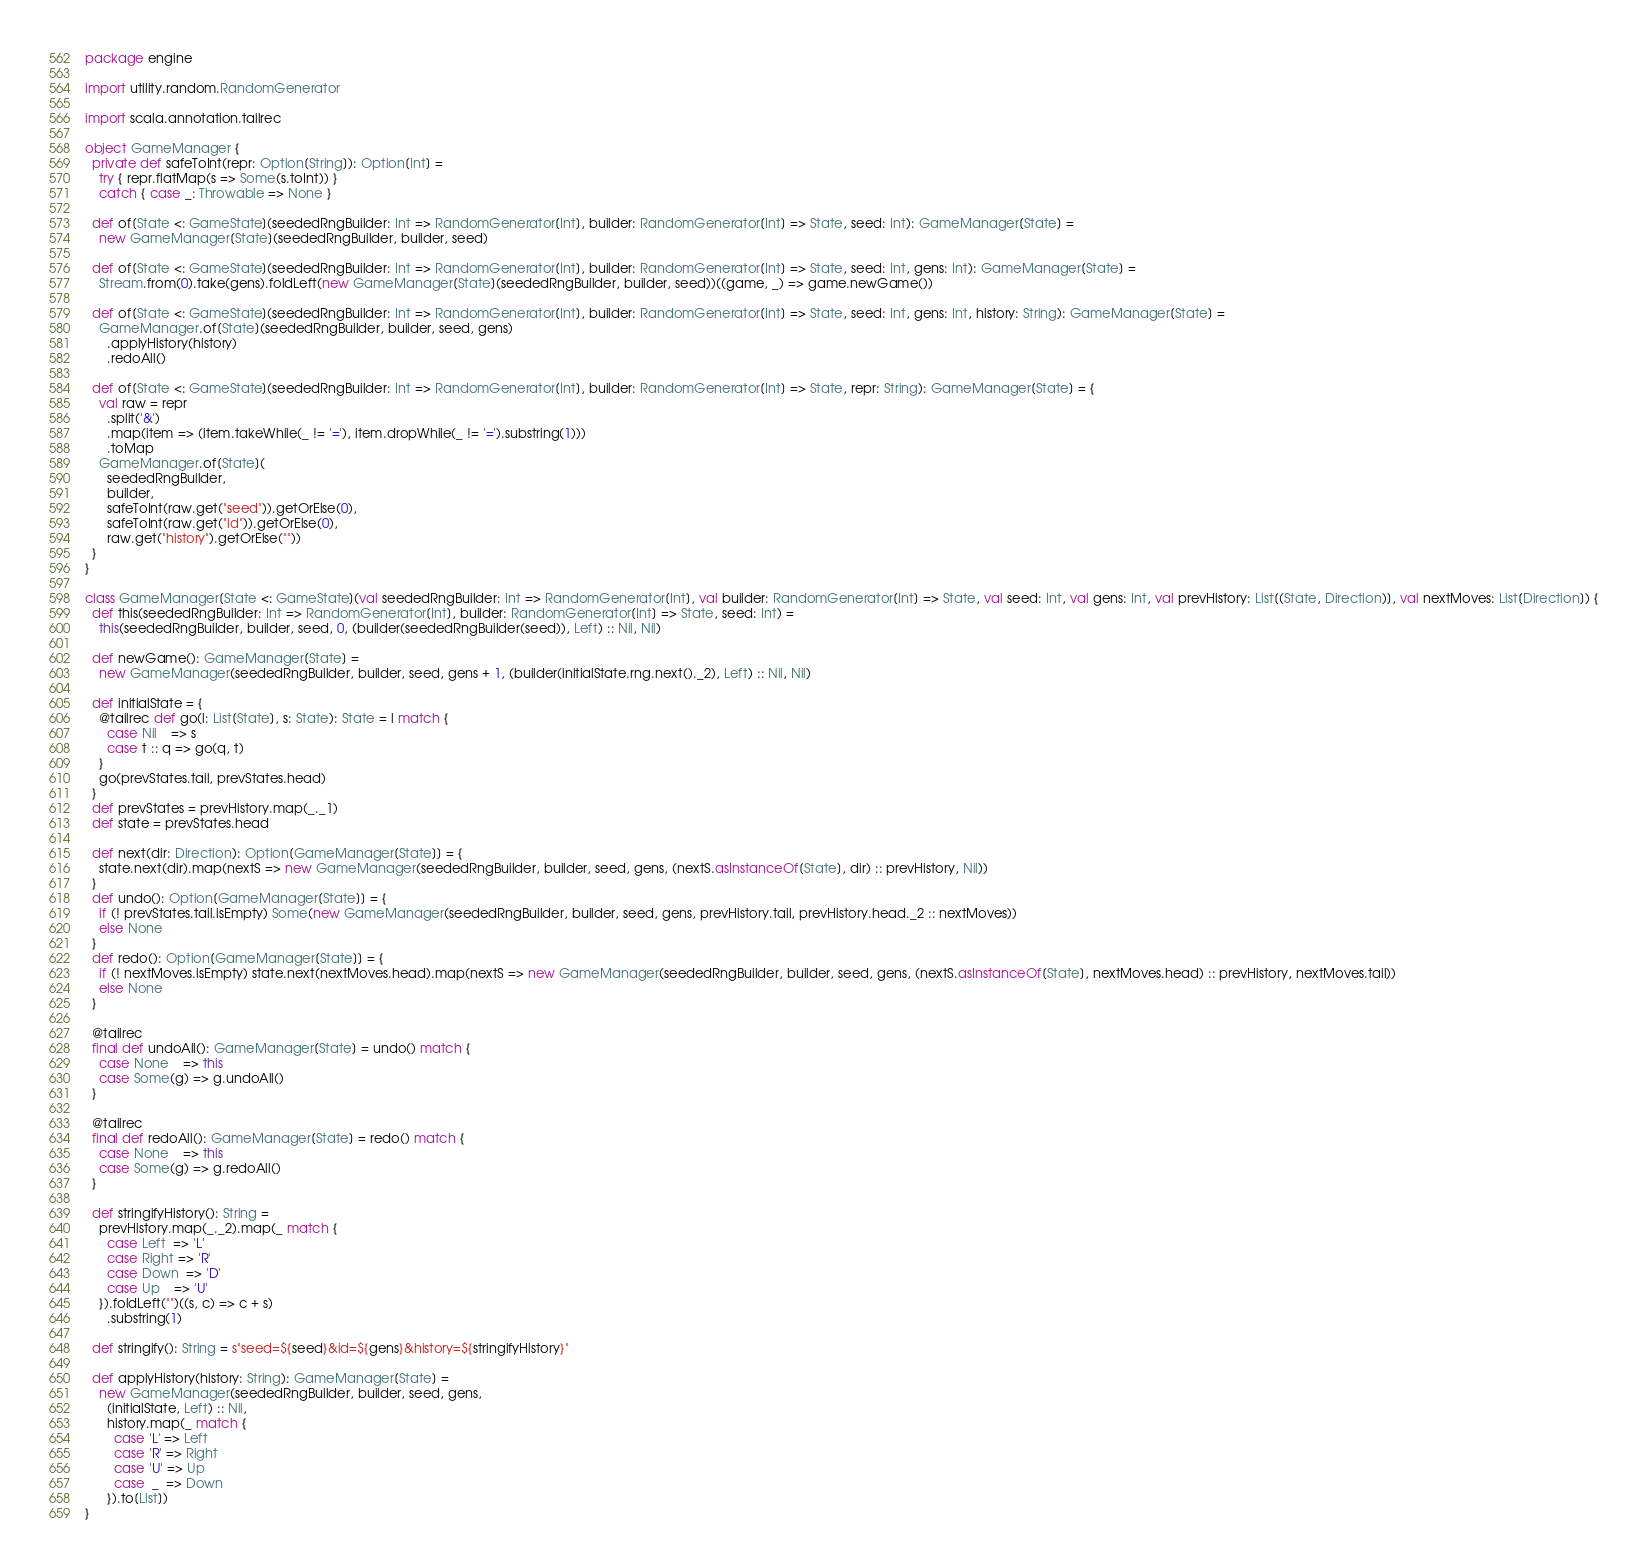Convert code to text. <code><loc_0><loc_0><loc_500><loc_500><_Scala_>package engine

import utility.random.RandomGenerator

import scala.annotation.tailrec

object GameManager {
  private def safeToInt(repr: Option[String]): Option[Int] =
    try { repr.flatMap(s => Some(s.toInt)) }
    catch { case _: Throwable => None }

  def of[State <: GameState](seededRngBuilder: Int => RandomGenerator[Int], builder: RandomGenerator[Int] => State, seed: Int): GameManager[State] =
    new GameManager[State](seededRngBuilder, builder, seed)

  def of[State <: GameState](seededRngBuilder: Int => RandomGenerator[Int], builder: RandomGenerator[Int] => State, seed: Int, gens: Int): GameManager[State] =
    Stream.from(0).take(gens).foldLeft(new GameManager[State](seededRngBuilder, builder, seed))((game, _) => game.newGame())

  def of[State <: GameState](seededRngBuilder: Int => RandomGenerator[Int], builder: RandomGenerator[Int] => State, seed: Int, gens: Int, history: String): GameManager[State] =
    GameManager.of[State](seededRngBuilder, builder, seed, gens)
      .applyHistory(history)
      .redoAll()

  def of[State <: GameState](seededRngBuilder: Int => RandomGenerator[Int], builder: RandomGenerator[Int] => State, repr: String): GameManager[State] = {
    val raw = repr
      .split('&')
      .map(item => (item.takeWhile(_ != '='), item.dropWhile(_ != '=').substring(1)))
      .toMap
    GameManager.of[State](
      seededRngBuilder,
      builder,
      safeToInt(raw.get("seed")).getOrElse(0),
      safeToInt(raw.get("id")).getOrElse(0),
      raw.get("history").getOrElse(""))
  }
}

class GameManager[State <: GameState](val seededRngBuilder: Int => RandomGenerator[Int], val builder: RandomGenerator[Int] => State, val seed: Int, val gens: Int, val prevHistory: List[(State, Direction)], val nextMoves: List[Direction]) {
  def this(seededRngBuilder: Int => RandomGenerator[Int], builder: RandomGenerator[Int] => State, seed: Int) =
    this(seededRngBuilder, builder, seed, 0, (builder(seededRngBuilder(seed)), Left) :: Nil, Nil)

  def newGame(): GameManager[State] =
    new GameManager(seededRngBuilder, builder, seed, gens + 1, (builder(initialState.rng.next()._2), Left) :: Nil, Nil)

  def initialState = {
    @tailrec def go(l: List[State], s: State): State = l match {
      case Nil    => s
      case t :: q => go(q, t)
    }
    go(prevStates.tail, prevStates.head)
  }
  def prevStates = prevHistory.map(_._1)
  def state = prevStates.head

  def next(dir: Direction): Option[GameManager[State]] = {
    state.next(dir).map(nextS => new GameManager(seededRngBuilder, builder, seed, gens, (nextS.asInstanceOf[State], dir) :: prevHistory, Nil))
  }
  def undo(): Option[GameManager[State]] = {
    if (! prevStates.tail.isEmpty) Some(new GameManager(seededRngBuilder, builder, seed, gens, prevHistory.tail, prevHistory.head._2 :: nextMoves))
    else None
  }
  def redo(): Option[GameManager[State]] = {
    if (! nextMoves.isEmpty) state.next(nextMoves.head).map(nextS => new GameManager(seededRngBuilder, builder, seed, gens, (nextS.asInstanceOf[State], nextMoves.head) :: prevHistory, nextMoves.tail))
    else None
  }

  @tailrec
  final def undoAll(): GameManager[State] = undo() match {
    case None    => this
    case Some(g) => g.undoAll()
  }

  @tailrec
  final def redoAll(): GameManager[State] = redo() match {
    case None    => this
    case Some(g) => g.redoAll()
  }

  def stringifyHistory(): String =
    prevHistory.map(_._2).map(_ match {
      case Left  => 'L'
      case Right => 'R'
      case Down  => 'D'
      case Up    => 'U'
    }).foldLeft("")((s, c) => c + s)
      .substring(1)

  def stringify(): String = s"seed=${seed}&id=${gens}&history=${stringifyHistory}"

  def applyHistory(history: String): GameManager[State] =
    new GameManager(seededRngBuilder, builder, seed, gens,
      (initialState, Left) :: Nil,
      history.map(_ match {
        case 'L' => Left
        case 'R' => Right
        case 'U' => Up
        case  _  => Down
      }).to[List])
}
</code> 